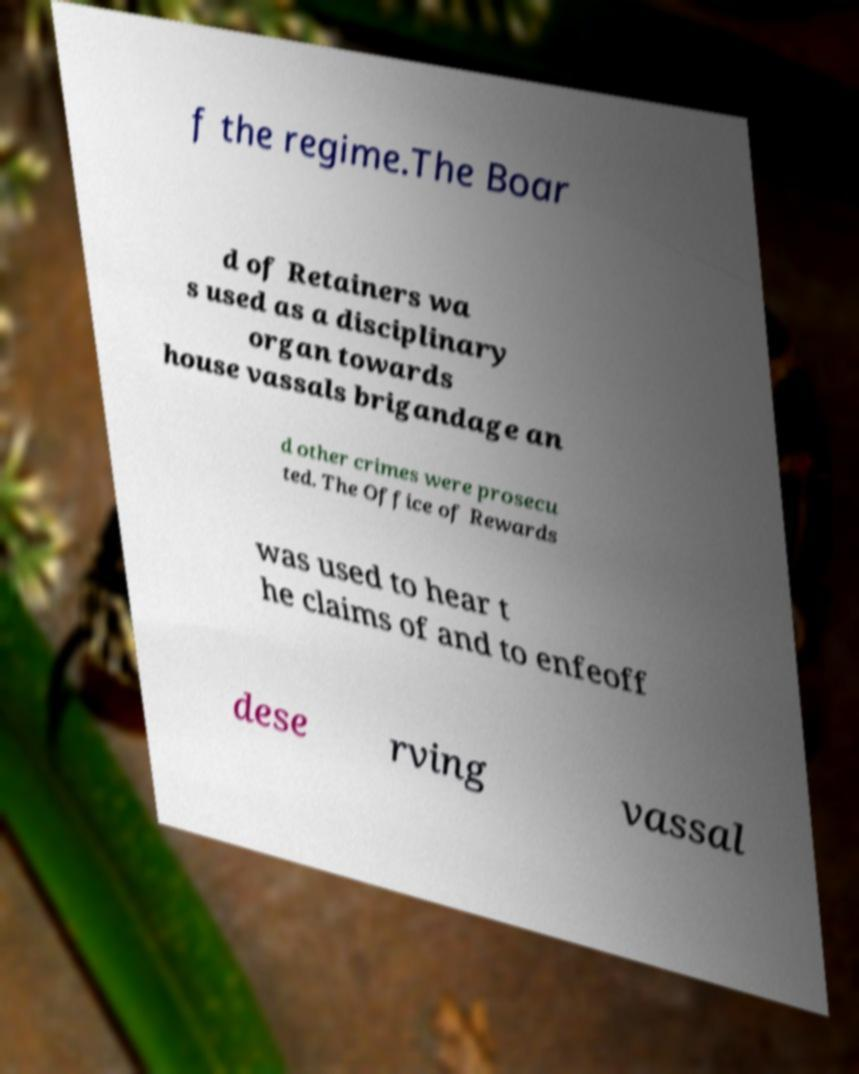Could you extract and type out the text from this image? f the regime.The Boar d of Retainers wa s used as a disciplinary organ towards house vassals brigandage an d other crimes were prosecu ted. The Office of Rewards was used to hear t he claims of and to enfeoff dese rving vassal 